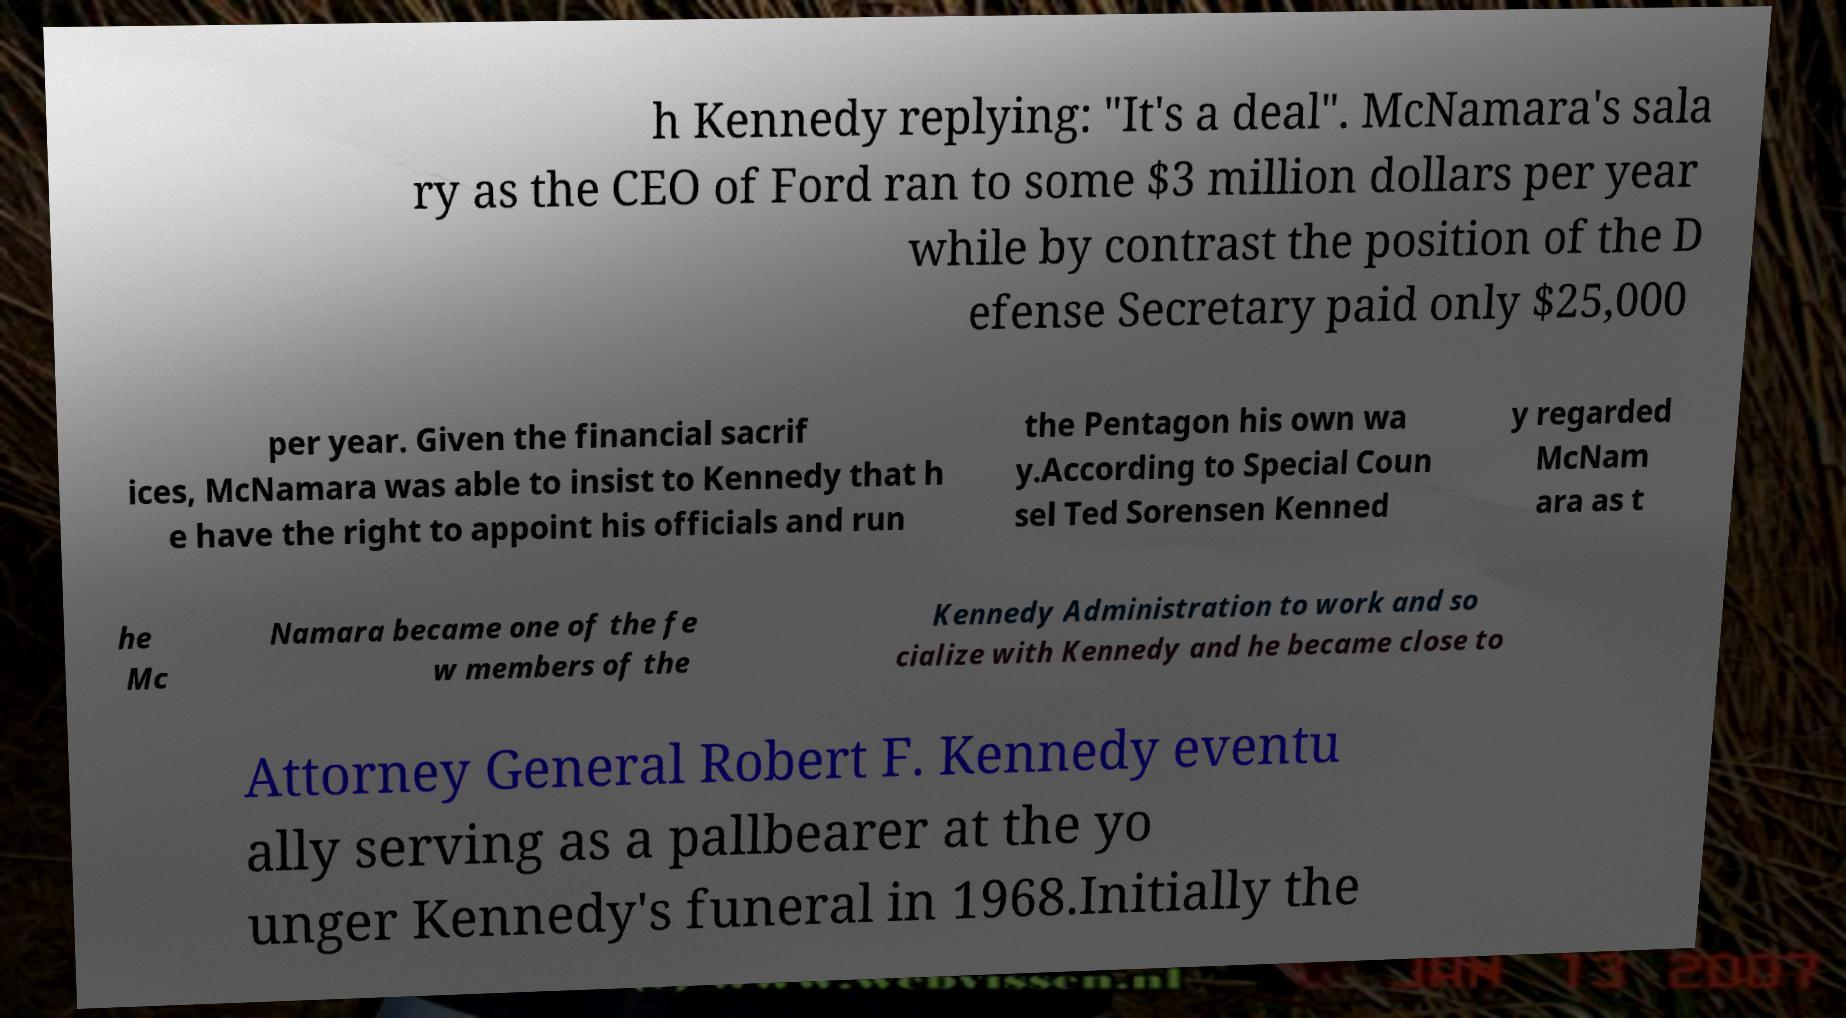Can you accurately transcribe the text from the provided image for me? h Kennedy replying: "It's a deal". McNamara's sala ry as the CEO of Ford ran to some $3 million dollars per year while by contrast the position of the D efense Secretary paid only $25,000 per year. Given the financial sacrif ices, McNamara was able to insist to Kennedy that h e have the right to appoint his officials and run the Pentagon his own wa y.According to Special Coun sel Ted Sorensen Kenned y regarded McNam ara as t he Mc Namara became one of the fe w members of the Kennedy Administration to work and so cialize with Kennedy and he became close to Attorney General Robert F. Kennedy eventu ally serving as a pallbearer at the yo unger Kennedy's funeral in 1968.Initially the 